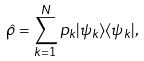Convert formula to latex. <formula><loc_0><loc_0><loc_500><loc_500>\hat { \rho } = \sum _ { k = 1 } ^ { N } p _ { k } | \psi _ { k } \rangle \langle \psi _ { k } | ,</formula> 